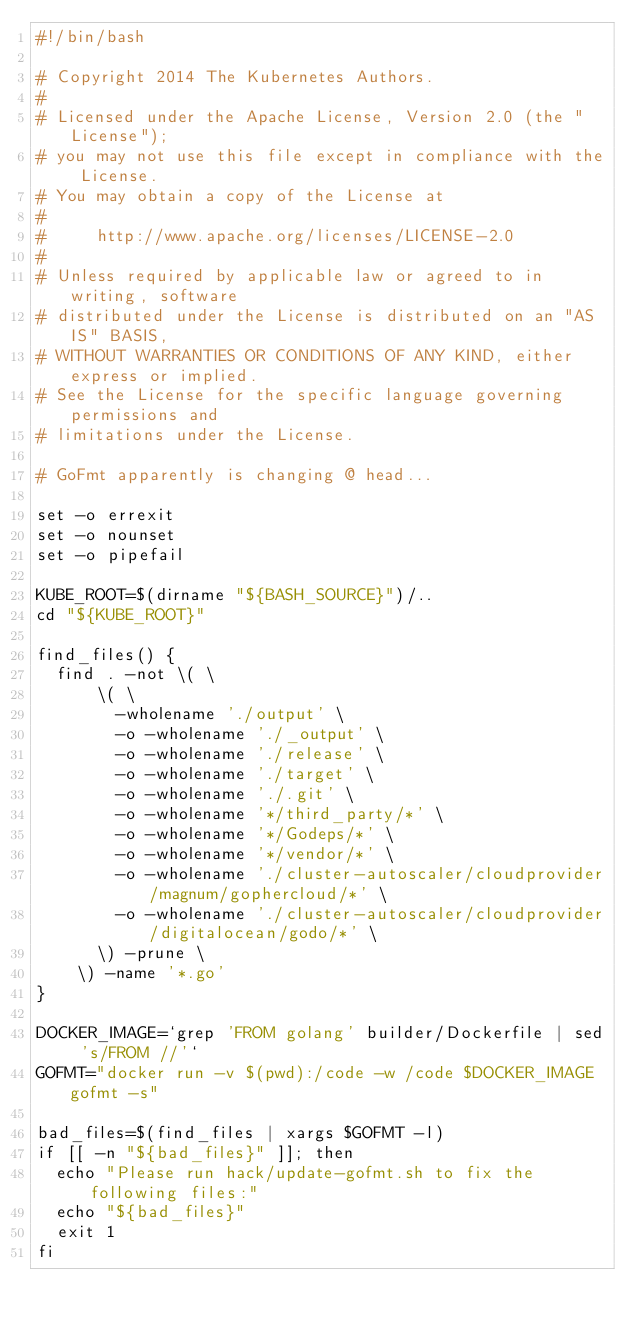Convert code to text. <code><loc_0><loc_0><loc_500><loc_500><_Bash_>#!/bin/bash

# Copyright 2014 The Kubernetes Authors.
#
# Licensed under the Apache License, Version 2.0 (the "License");
# you may not use this file except in compliance with the License.
# You may obtain a copy of the License at
#
#     http://www.apache.org/licenses/LICENSE-2.0
#
# Unless required by applicable law or agreed to in writing, software
# distributed under the License is distributed on an "AS IS" BASIS,
# WITHOUT WARRANTIES OR CONDITIONS OF ANY KIND, either express or implied.
# See the License for the specific language governing permissions and
# limitations under the License.

# GoFmt apparently is changing @ head...

set -o errexit
set -o nounset
set -o pipefail

KUBE_ROOT=$(dirname "${BASH_SOURCE}")/..
cd "${KUBE_ROOT}"

find_files() {
  find . -not \( \
      \( \
        -wholename './output' \
        -o -wholename './_output' \
        -o -wholename './release' \
        -o -wholename './target' \
        -o -wholename './.git' \
        -o -wholename '*/third_party/*' \
        -o -wholename '*/Godeps/*' \
        -o -wholename '*/vendor/*' \
        -o -wholename './cluster-autoscaler/cloudprovider/magnum/gophercloud/*' \
        -o -wholename './cluster-autoscaler/cloudprovider/digitalocean/godo/*' \
      \) -prune \
    \) -name '*.go'
}

DOCKER_IMAGE=`grep 'FROM golang' builder/Dockerfile | sed 's/FROM //'`
GOFMT="docker run -v $(pwd):/code -w /code $DOCKER_IMAGE gofmt -s"

bad_files=$(find_files | xargs $GOFMT -l)
if [[ -n "${bad_files}" ]]; then
  echo "Please run hack/update-gofmt.sh to fix the following files:"
  echo "${bad_files}"
  exit 1
fi
</code> 